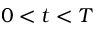Convert formula to latex. <formula><loc_0><loc_0><loc_500><loc_500>0 < t < T</formula> 